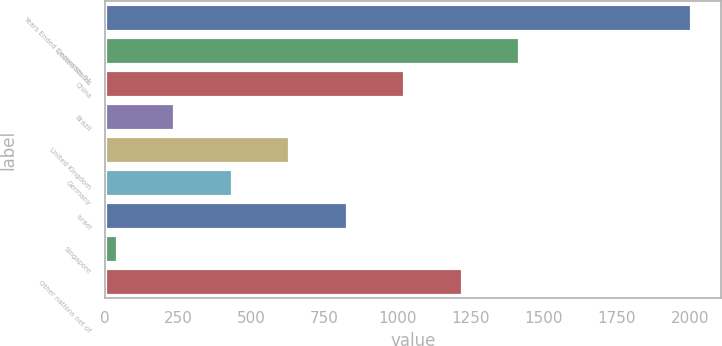Convert chart. <chart><loc_0><loc_0><loc_500><loc_500><bar_chart><fcel>Years Ended December 31<fcel>United States<fcel>China<fcel>Brazil<fcel>United Kingdom<fcel>Germany<fcel>Israel<fcel>Singapore<fcel>Other nations net of<nl><fcel>2006<fcel>1415.9<fcel>1022.5<fcel>235.7<fcel>629.1<fcel>432.4<fcel>825.8<fcel>39<fcel>1219.2<nl></chart> 